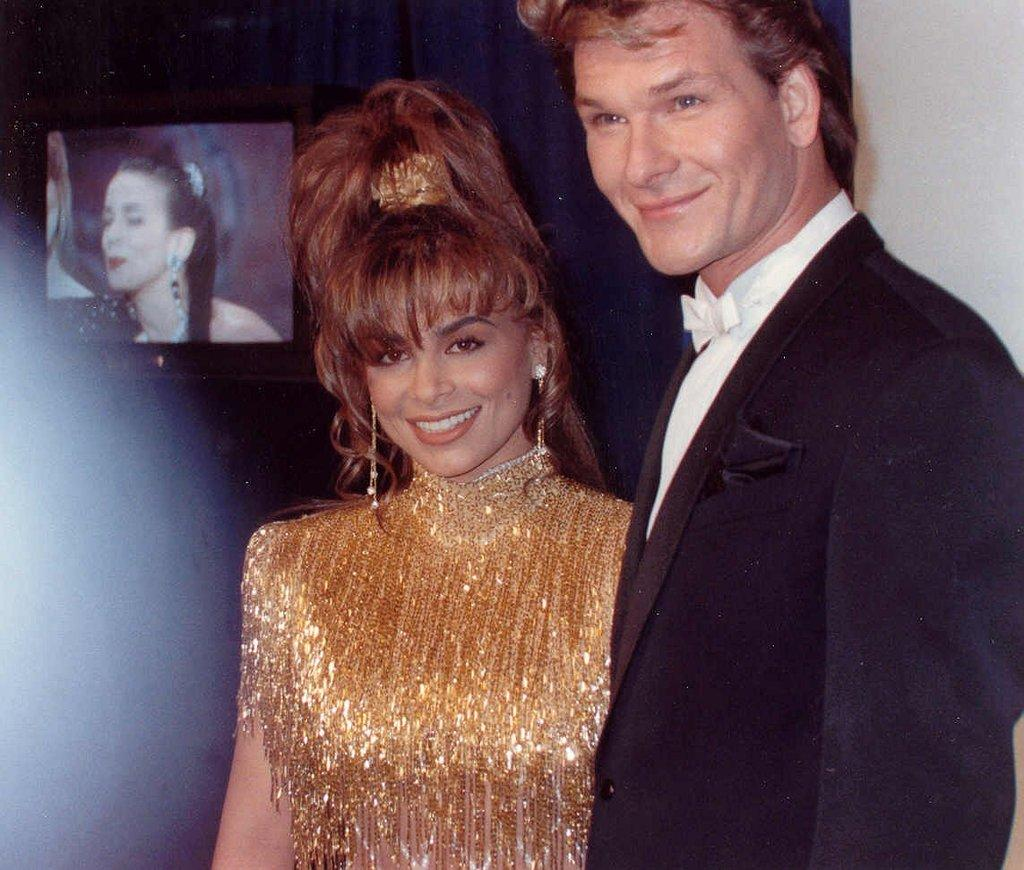Who is present in the image? There is a man and a woman in the image. What are the facial expressions of the people in the image? Both the man and the woman are smiling in the image. What electronic device is visible in the image? There is a television visible in the image. What type of toy is the man holding in the image? There is no toy present in the image; the man is not holding anything. 